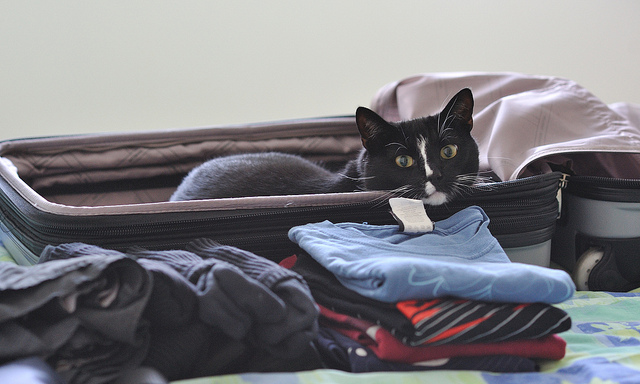<image>What shirt will the cat where? It is uncertain what shirt the cat will wear. It could be blue or none. What shirt will the cat where? I don't know what shirt the cat will wear. It can be either blue or none. 